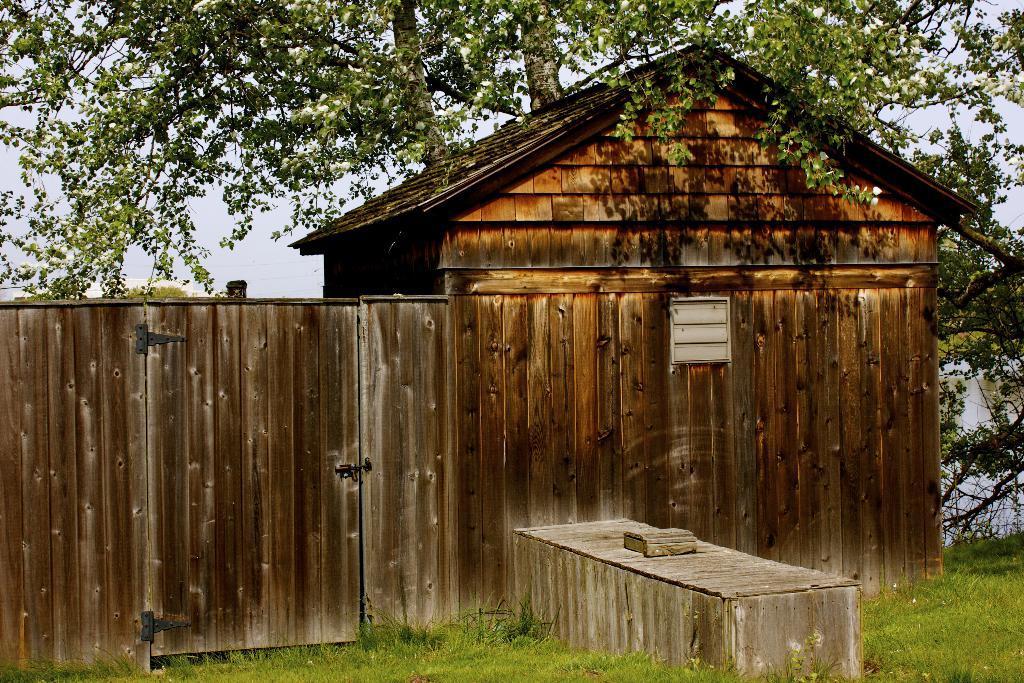Can you describe this image briefly? In this image we can see a wooden house, behind it one tree is present. In front of the house one wooden box and grass is there. 